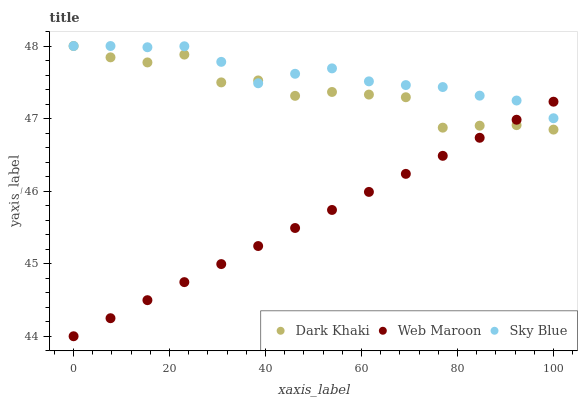Does Web Maroon have the minimum area under the curve?
Answer yes or no. Yes. Does Sky Blue have the maximum area under the curve?
Answer yes or no. Yes. Does Sky Blue have the minimum area under the curve?
Answer yes or no. No. Does Web Maroon have the maximum area under the curve?
Answer yes or no. No. Is Web Maroon the smoothest?
Answer yes or no. Yes. Is Dark Khaki the roughest?
Answer yes or no. Yes. Is Sky Blue the smoothest?
Answer yes or no. No. Is Sky Blue the roughest?
Answer yes or no. No. Does Web Maroon have the lowest value?
Answer yes or no. Yes. Does Sky Blue have the lowest value?
Answer yes or no. No. Does Sky Blue have the highest value?
Answer yes or no. Yes. Does Web Maroon have the highest value?
Answer yes or no. No. Does Web Maroon intersect Sky Blue?
Answer yes or no. Yes. Is Web Maroon less than Sky Blue?
Answer yes or no. No. Is Web Maroon greater than Sky Blue?
Answer yes or no. No. 